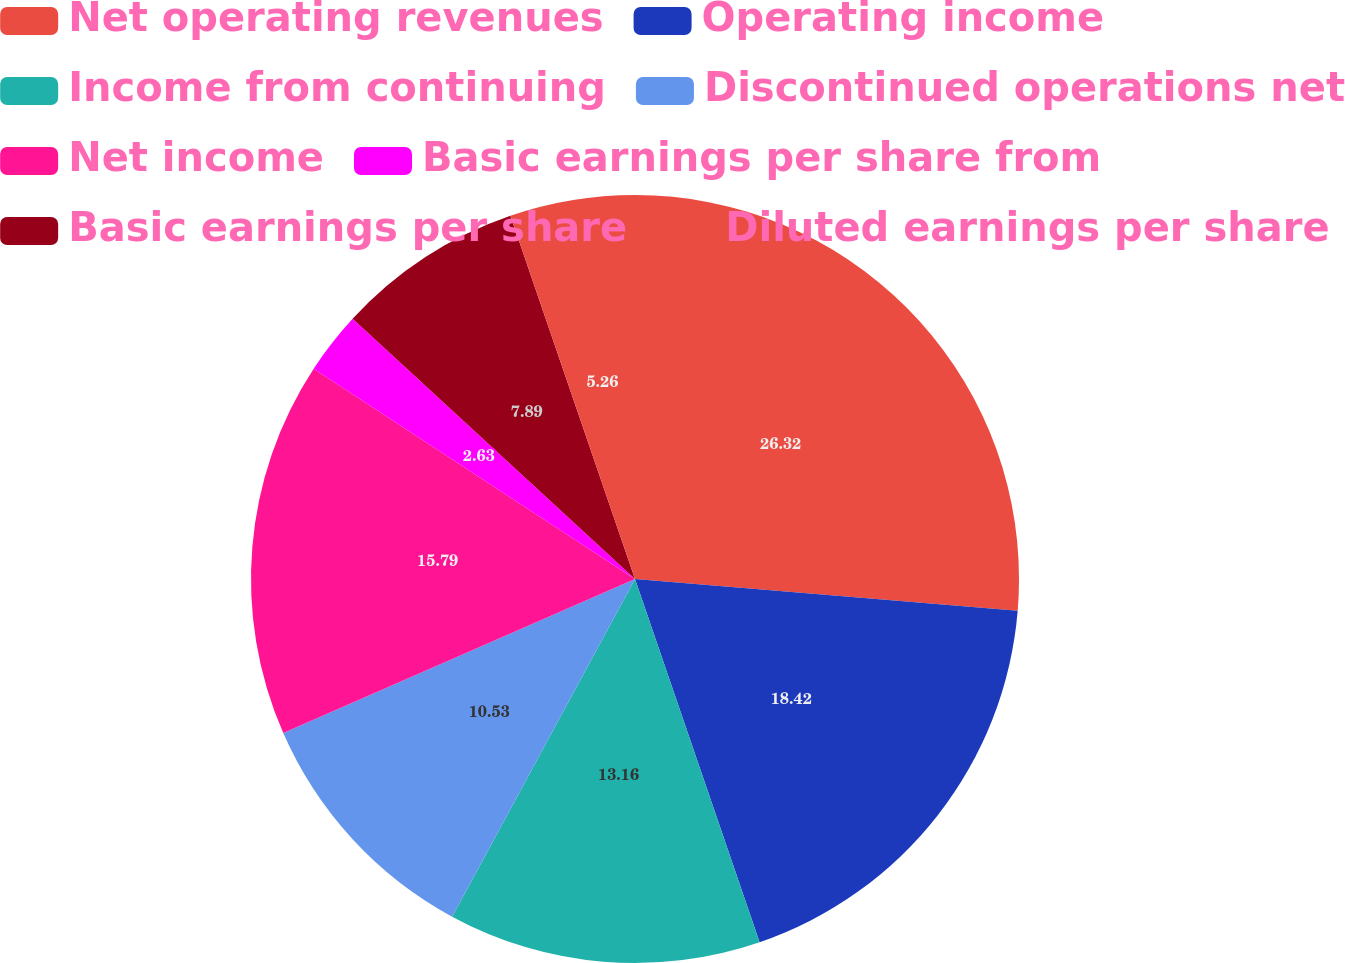<chart> <loc_0><loc_0><loc_500><loc_500><pie_chart><fcel>Net operating revenues<fcel>Operating income<fcel>Income from continuing<fcel>Discontinued operations net<fcel>Net income<fcel>Basic earnings per share from<fcel>Basic earnings per share<fcel>Diluted earnings per share<nl><fcel>26.32%<fcel>18.42%<fcel>13.16%<fcel>10.53%<fcel>15.79%<fcel>2.63%<fcel>7.89%<fcel>5.26%<nl></chart> 